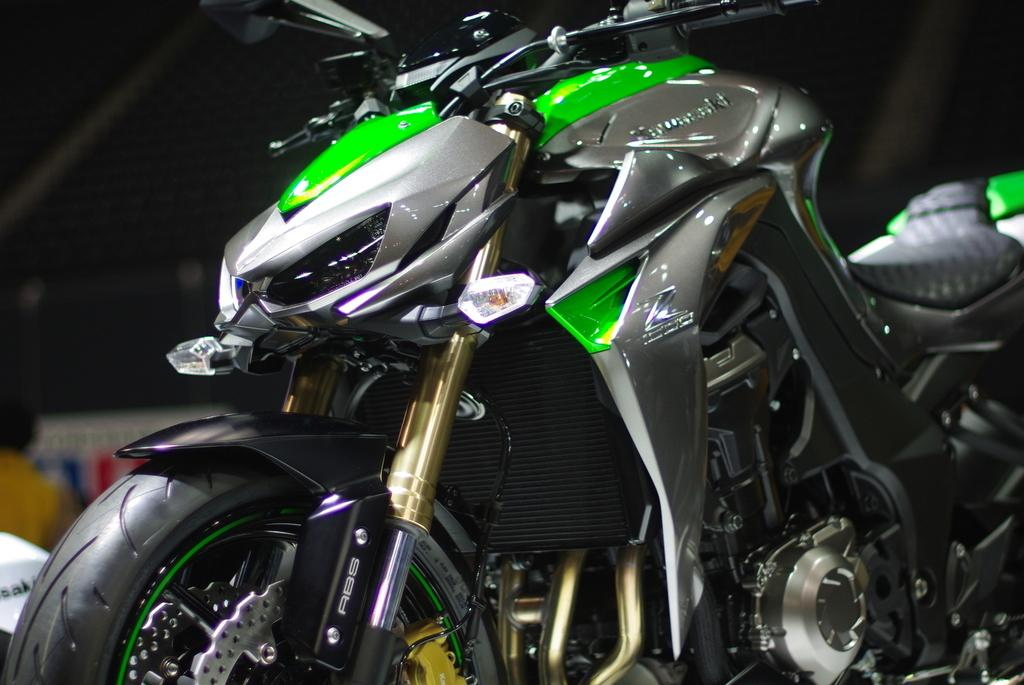What is the main subject of the image? The main subject of the image is a bike. Can you describe the background of the image? The background of the image is dark. Are there any people or objects visible in the background? Yes, there is a person visible in the background, as well as a board. What type of muscle is being flexed by the person in the image? There is no person flexing a muscle in the image; the person is simply visible in the background. Can you tell me how many pickles are on the bike in the image? There are no pickles present in the image; the main subject is a bike. 